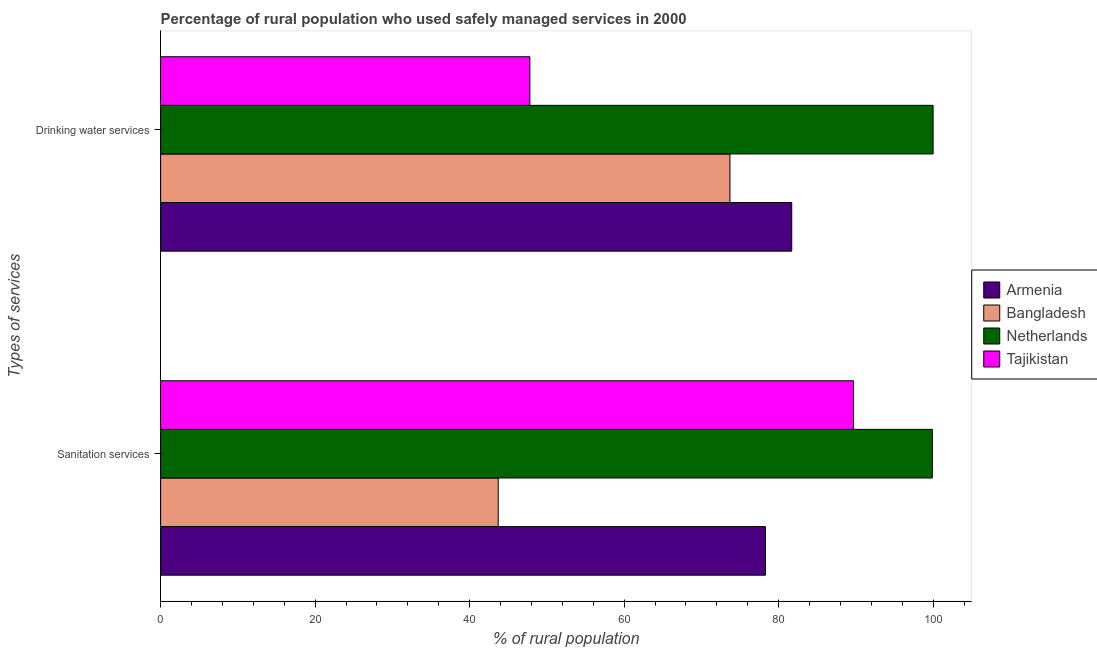Are the number of bars per tick equal to the number of legend labels?
Offer a terse response. Yes. How many bars are there on the 2nd tick from the top?
Make the answer very short. 4. How many bars are there on the 1st tick from the bottom?
Provide a succinct answer. 4. What is the label of the 2nd group of bars from the top?
Offer a very short reply. Sanitation services. What is the percentage of rural population who used drinking water services in Armenia?
Provide a succinct answer. 81.7. Across all countries, what is the maximum percentage of rural population who used sanitation services?
Ensure brevity in your answer.  99.9. Across all countries, what is the minimum percentage of rural population who used drinking water services?
Give a very brief answer. 47.8. In which country was the percentage of rural population who used sanitation services minimum?
Your answer should be very brief. Bangladesh. What is the total percentage of rural population who used drinking water services in the graph?
Ensure brevity in your answer.  303.2. What is the difference between the percentage of rural population who used sanitation services in Bangladesh and that in Tajikistan?
Offer a very short reply. -46. What is the difference between the percentage of rural population who used sanitation services in Armenia and the percentage of rural population who used drinking water services in Tajikistan?
Keep it short and to the point. 30.5. What is the average percentage of rural population who used sanitation services per country?
Your answer should be very brief. 77.9. What is the difference between the percentage of rural population who used drinking water services and percentage of rural population who used sanitation services in Tajikistan?
Offer a very short reply. -41.9. What is the ratio of the percentage of rural population who used drinking water services in Armenia to that in Tajikistan?
Make the answer very short. 1.71. What does the 4th bar from the top in Drinking water services represents?
Provide a short and direct response. Armenia. What is the difference between two consecutive major ticks on the X-axis?
Keep it short and to the point. 20. Does the graph contain any zero values?
Offer a very short reply. No. Does the graph contain grids?
Your answer should be compact. No. Where does the legend appear in the graph?
Your answer should be compact. Center right. What is the title of the graph?
Your answer should be very brief. Percentage of rural population who used safely managed services in 2000. What is the label or title of the X-axis?
Offer a terse response. % of rural population. What is the label or title of the Y-axis?
Provide a succinct answer. Types of services. What is the % of rural population of Armenia in Sanitation services?
Keep it short and to the point. 78.3. What is the % of rural population of Bangladesh in Sanitation services?
Provide a succinct answer. 43.7. What is the % of rural population in Netherlands in Sanitation services?
Provide a short and direct response. 99.9. What is the % of rural population in Tajikistan in Sanitation services?
Your response must be concise. 89.7. What is the % of rural population of Armenia in Drinking water services?
Offer a very short reply. 81.7. What is the % of rural population of Bangladesh in Drinking water services?
Offer a very short reply. 73.7. What is the % of rural population in Tajikistan in Drinking water services?
Provide a succinct answer. 47.8. Across all Types of services, what is the maximum % of rural population in Armenia?
Offer a very short reply. 81.7. Across all Types of services, what is the maximum % of rural population of Bangladesh?
Give a very brief answer. 73.7. Across all Types of services, what is the maximum % of rural population of Netherlands?
Your answer should be very brief. 100. Across all Types of services, what is the maximum % of rural population in Tajikistan?
Provide a short and direct response. 89.7. Across all Types of services, what is the minimum % of rural population in Armenia?
Your response must be concise. 78.3. Across all Types of services, what is the minimum % of rural population in Bangladesh?
Offer a very short reply. 43.7. Across all Types of services, what is the minimum % of rural population of Netherlands?
Your response must be concise. 99.9. Across all Types of services, what is the minimum % of rural population in Tajikistan?
Make the answer very short. 47.8. What is the total % of rural population in Armenia in the graph?
Offer a very short reply. 160. What is the total % of rural population of Bangladesh in the graph?
Your answer should be very brief. 117.4. What is the total % of rural population in Netherlands in the graph?
Ensure brevity in your answer.  199.9. What is the total % of rural population of Tajikistan in the graph?
Make the answer very short. 137.5. What is the difference between the % of rural population in Tajikistan in Sanitation services and that in Drinking water services?
Your answer should be compact. 41.9. What is the difference between the % of rural population of Armenia in Sanitation services and the % of rural population of Bangladesh in Drinking water services?
Offer a very short reply. 4.6. What is the difference between the % of rural population of Armenia in Sanitation services and the % of rural population of Netherlands in Drinking water services?
Give a very brief answer. -21.7. What is the difference between the % of rural population in Armenia in Sanitation services and the % of rural population in Tajikistan in Drinking water services?
Your answer should be very brief. 30.5. What is the difference between the % of rural population in Bangladesh in Sanitation services and the % of rural population in Netherlands in Drinking water services?
Your answer should be compact. -56.3. What is the difference between the % of rural population in Bangladesh in Sanitation services and the % of rural population in Tajikistan in Drinking water services?
Offer a terse response. -4.1. What is the difference between the % of rural population in Netherlands in Sanitation services and the % of rural population in Tajikistan in Drinking water services?
Ensure brevity in your answer.  52.1. What is the average % of rural population of Armenia per Types of services?
Offer a terse response. 80. What is the average % of rural population in Bangladesh per Types of services?
Make the answer very short. 58.7. What is the average % of rural population of Netherlands per Types of services?
Your answer should be compact. 99.95. What is the average % of rural population in Tajikistan per Types of services?
Make the answer very short. 68.75. What is the difference between the % of rural population of Armenia and % of rural population of Bangladesh in Sanitation services?
Offer a terse response. 34.6. What is the difference between the % of rural population in Armenia and % of rural population in Netherlands in Sanitation services?
Provide a short and direct response. -21.6. What is the difference between the % of rural population in Bangladesh and % of rural population in Netherlands in Sanitation services?
Give a very brief answer. -56.2. What is the difference between the % of rural population of Bangladesh and % of rural population of Tajikistan in Sanitation services?
Keep it short and to the point. -46. What is the difference between the % of rural population of Netherlands and % of rural population of Tajikistan in Sanitation services?
Provide a short and direct response. 10.2. What is the difference between the % of rural population in Armenia and % of rural population in Bangladesh in Drinking water services?
Your response must be concise. 8. What is the difference between the % of rural population of Armenia and % of rural population of Netherlands in Drinking water services?
Give a very brief answer. -18.3. What is the difference between the % of rural population of Armenia and % of rural population of Tajikistan in Drinking water services?
Keep it short and to the point. 33.9. What is the difference between the % of rural population in Bangladesh and % of rural population in Netherlands in Drinking water services?
Keep it short and to the point. -26.3. What is the difference between the % of rural population of Bangladesh and % of rural population of Tajikistan in Drinking water services?
Your response must be concise. 25.9. What is the difference between the % of rural population in Netherlands and % of rural population in Tajikistan in Drinking water services?
Your answer should be compact. 52.2. What is the ratio of the % of rural population in Armenia in Sanitation services to that in Drinking water services?
Your answer should be compact. 0.96. What is the ratio of the % of rural population in Bangladesh in Sanitation services to that in Drinking water services?
Keep it short and to the point. 0.59. What is the ratio of the % of rural population in Netherlands in Sanitation services to that in Drinking water services?
Offer a very short reply. 1. What is the ratio of the % of rural population in Tajikistan in Sanitation services to that in Drinking water services?
Your answer should be compact. 1.88. What is the difference between the highest and the second highest % of rural population of Tajikistan?
Provide a short and direct response. 41.9. What is the difference between the highest and the lowest % of rural population of Bangladesh?
Your answer should be very brief. 30. What is the difference between the highest and the lowest % of rural population in Netherlands?
Your answer should be very brief. 0.1. What is the difference between the highest and the lowest % of rural population of Tajikistan?
Give a very brief answer. 41.9. 